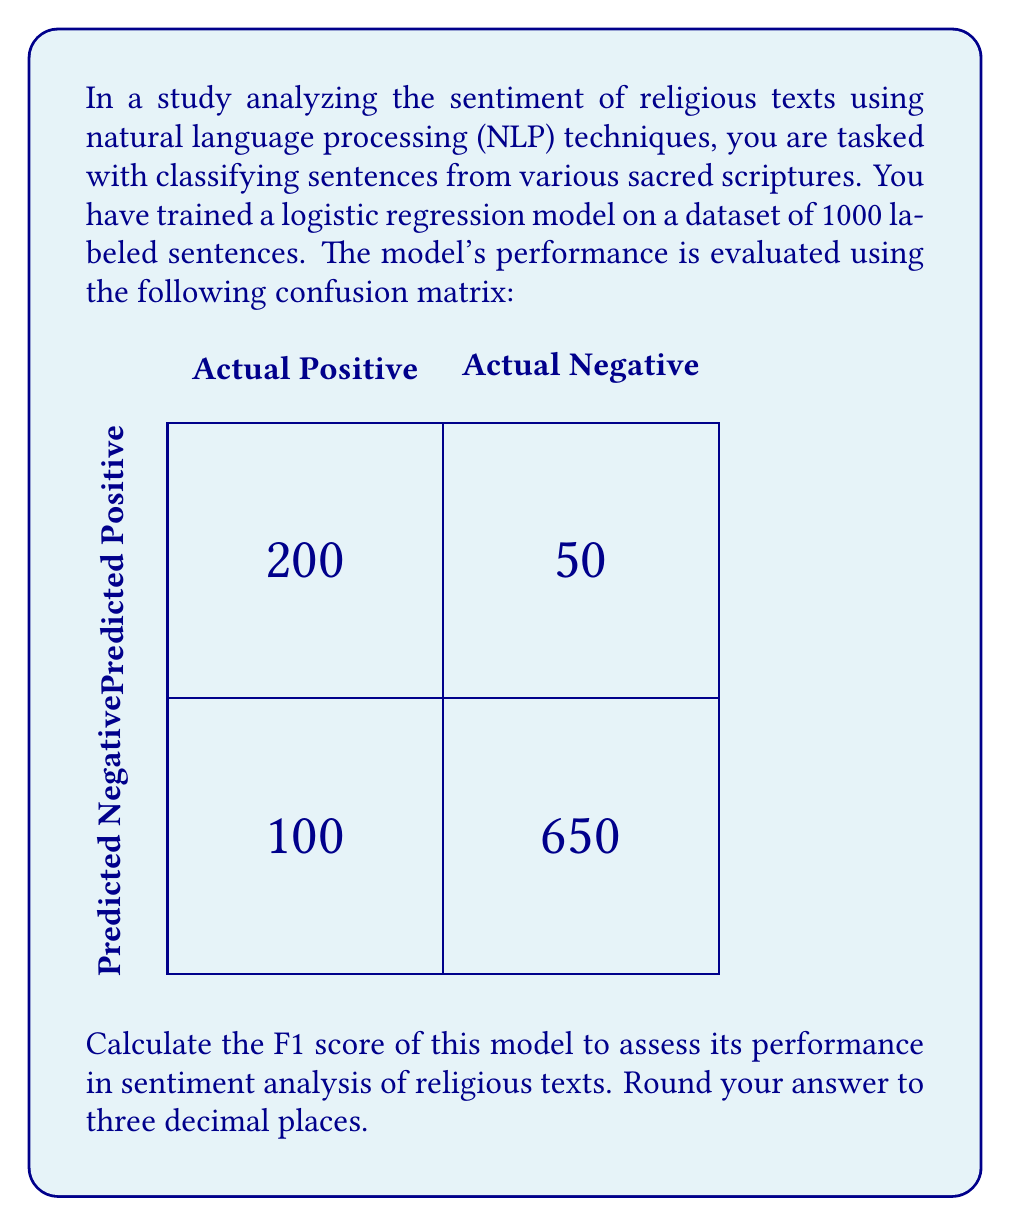Can you answer this question? To calculate the F1 score, we need to follow these steps:

1. Calculate Precision:
   Precision = True Positives / (True Positives + False Positives)
   $$ \text{Precision} = \frac{200}{200 + 50} = \frac{200}{250} = 0.8 $$

2. Calculate Recall:
   Recall = True Positives / (True Positives + False Negatives)
   $$ \text{Recall} = \frac{200}{200 + 100} = \frac{200}{300} \approx 0.6667 $$

3. Calculate F1 score:
   The F1 score is the harmonic mean of precision and recall, given by the formula:
   $$ F1 = 2 \cdot \frac{\text{Precision} \cdot \text{Recall}}{\text{Precision} + \text{Recall}} $$

   Substituting the values:
   $$ F1 = 2 \cdot \frac{0.8 \cdot 0.6667}{0.8 + 0.6667} $$
   $$ = 2 \cdot \frac{0.53336}{1.4667} $$
   $$ \approx 0.7273 $$

4. Rounding to three decimal places:
   F1 score ≈ 0.727

This F1 score indicates a balanced performance between precision and recall in the sentiment analysis of religious texts, which is crucial for understanding the nuanced language often found in sacred scriptures.
Answer: 0.727 